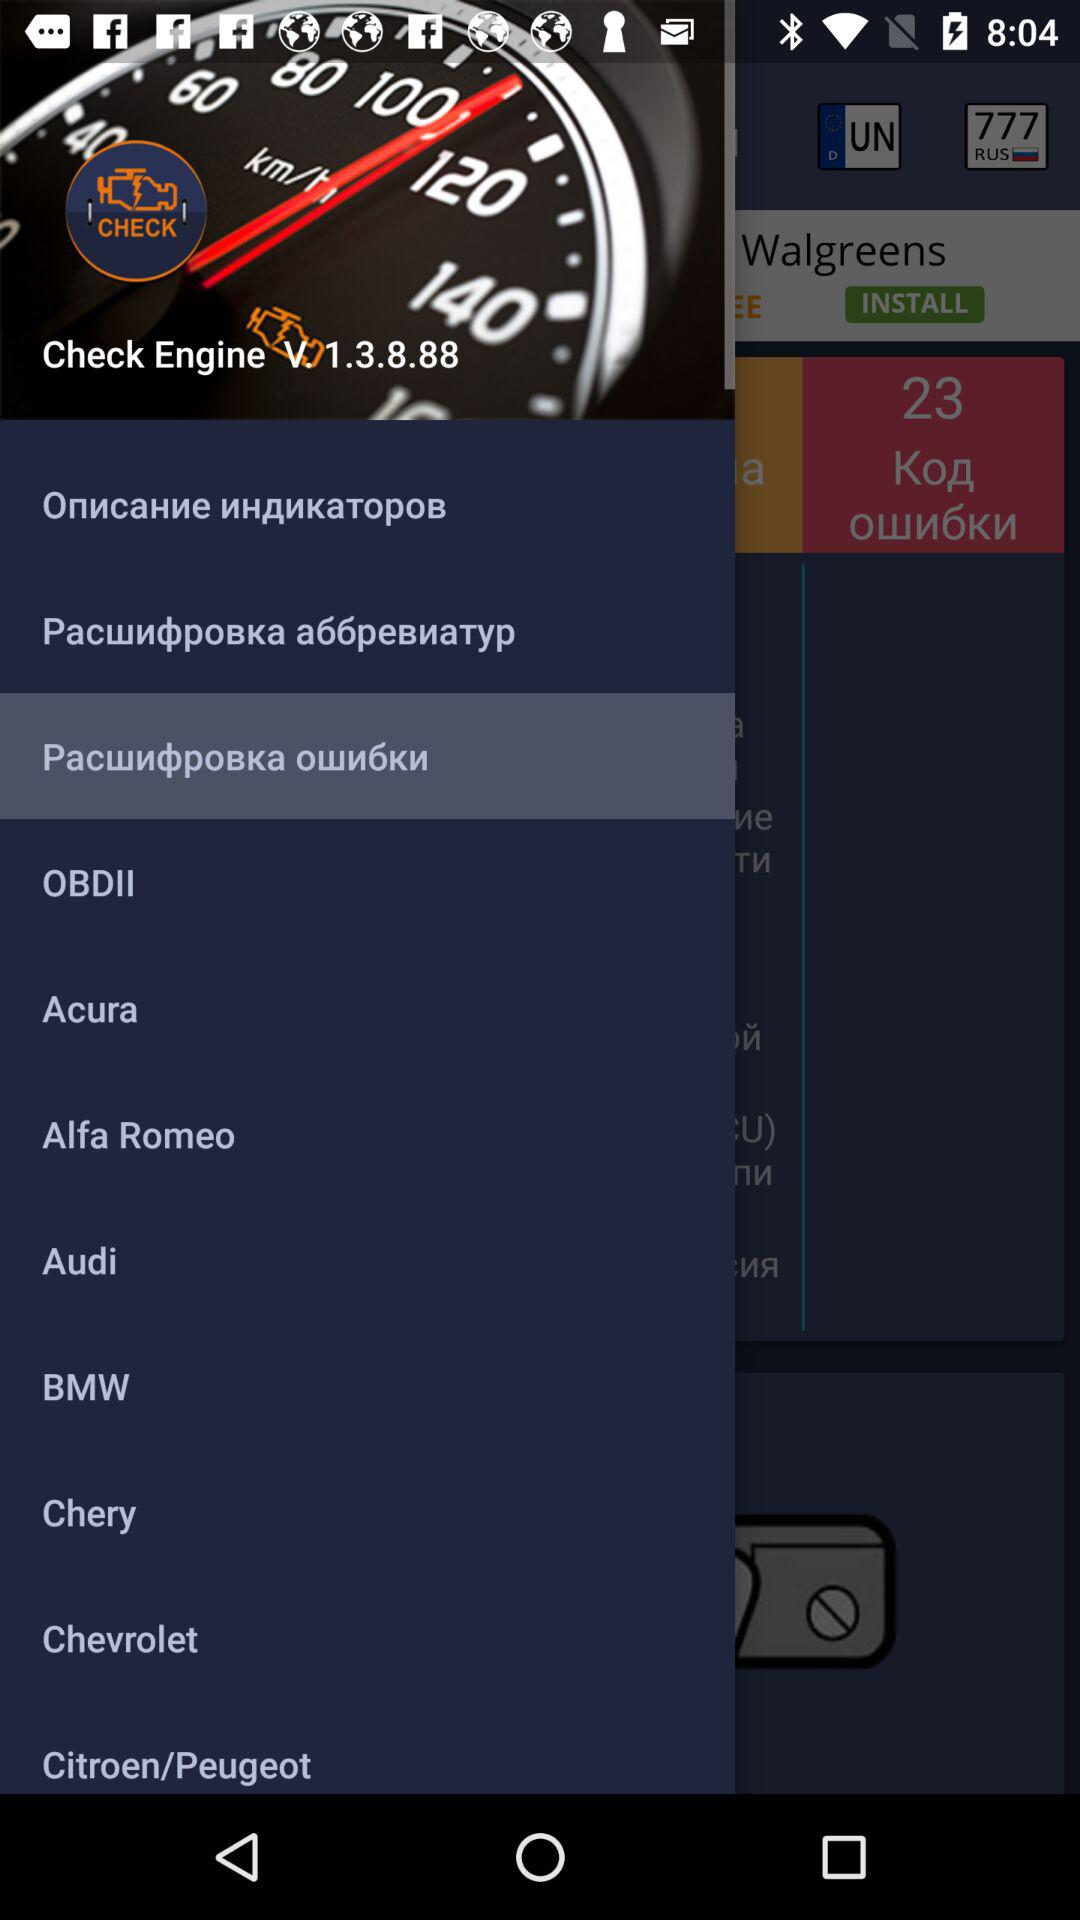What version of the application is being used? The version that is being used is V. 1.3.8.88. 